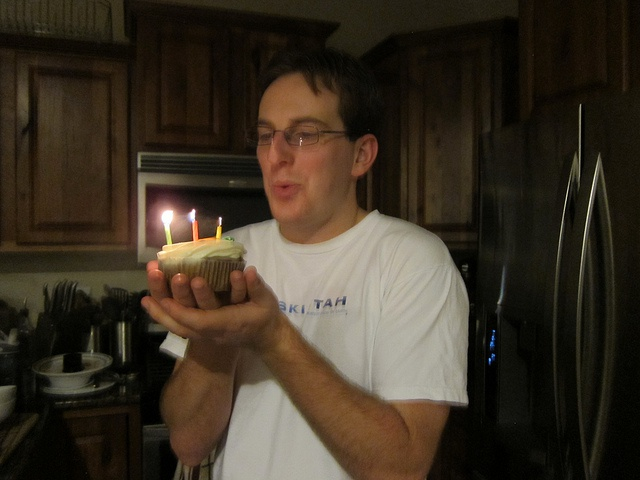Describe the objects in this image and their specific colors. I can see people in black, darkgray, and maroon tones, refrigerator in black, gray, and darkgreen tones, microwave in black, gray, and maroon tones, cake in black, tan, olive, and gray tones, and oven in black, maroon, and gray tones in this image. 